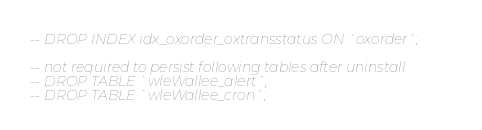Convert code to text. <code><loc_0><loc_0><loc_500><loc_500><_SQL_>-- DROP INDEX idx_oxorder_oxtransstatus ON `oxorder`;

-- not required to persist following tables after uninstall
-- DROP TABLE `wleWallee_alert`;
-- DROP TABLE `wleWallee_cron`;</code> 